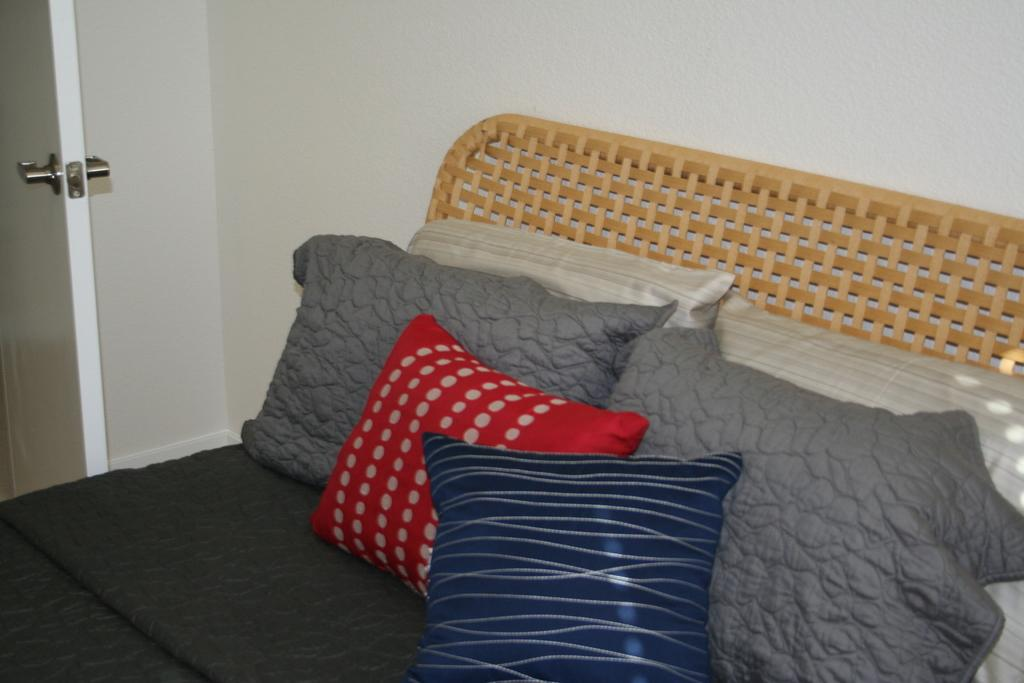Where is the image taken? The image is inside a room. What furniture is present in the room? There is a bed in the room. What is covering the bed? A blanket is present on the bed. Where are the pillows located on the bed? Pillows are on the left side of the bed. What can be seen in the background of the room? There is a door in the background of the room, and the wall is white. Can you see a robin using a whip to aid its digestion in the image? No, there is no robin or whip present in the image, and the image does not depict any digestion-related activities. 